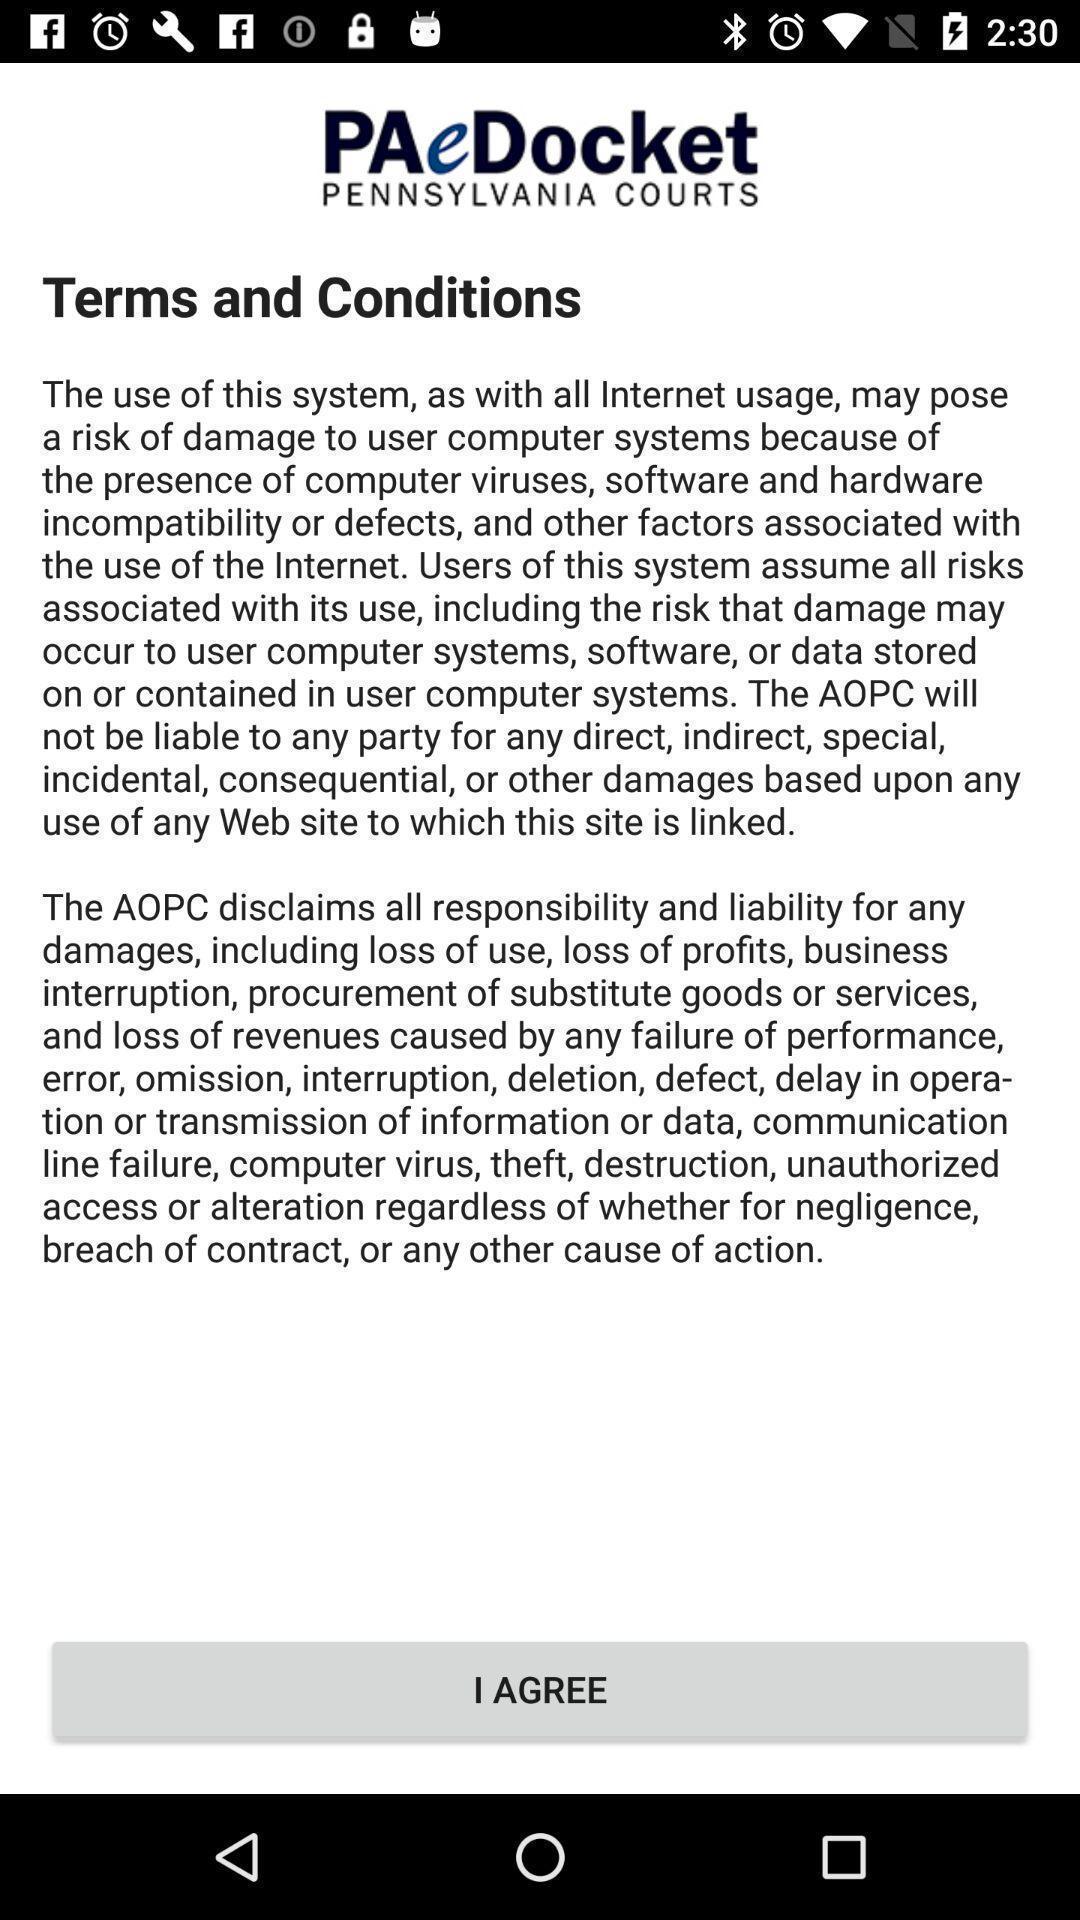Explain the elements present in this screenshot. Various terms and condition page displayed s. 